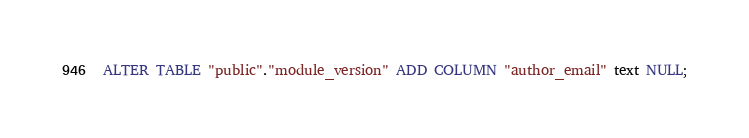<code> <loc_0><loc_0><loc_500><loc_500><_SQL_>ALTER TABLE "public"."module_version" ADD COLUMN "author_email" text NULL;
</code> 